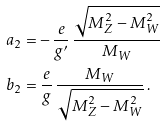<formula> <loc_0><loc_0><loc_500><loc_500>a _ { 2 } & = - \, \frac { e } { g ^ { \prime } } \, \frac { \sqrt { M _ { Z } ^ { 2 } - M _ { W } ^ { 2 } } } { M _ { W } } \\ b _ { 2 } & = \frac { e } { g } \, \frac { M _ { W } } { \sqrt { M _ { Z } ^ { 2 } - M _ { W } ^ { 2 } } } \, .</formula> 